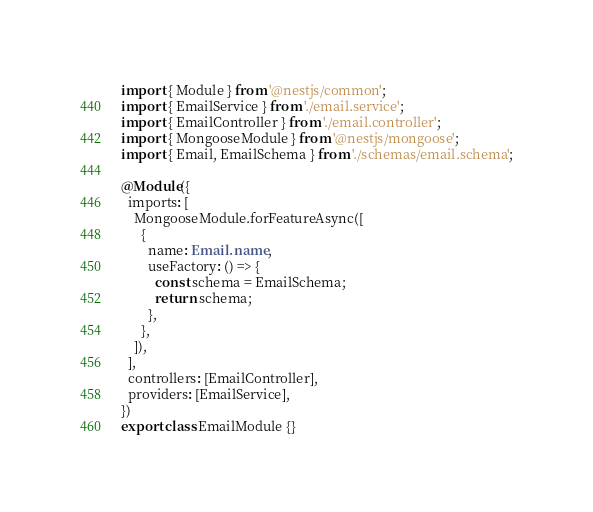Convert code to text. <code><loc_0><loc_0><loc_500><loc_500><_TypeScript_>import { Module } from '@nestjs/common';
import { EmailService } from './email.service';
import { EmailController } from './email.controller';
import { MongooseModule } from '@nestjs/mongoose';
import { Email, EmailSchema } from './schemas/email.schema';

@Module({
  imports: [
    MongooseModule.forFeatureAsync([
      {
        name: Email.name,
        useFactory: () => {
          const schema = EmailSchema;
          return schema;
        },
      },
    ]),
  ],
  controllers: [EmailController],
  providers: [EmailService],
})
export class EmailModule {}
</code> 